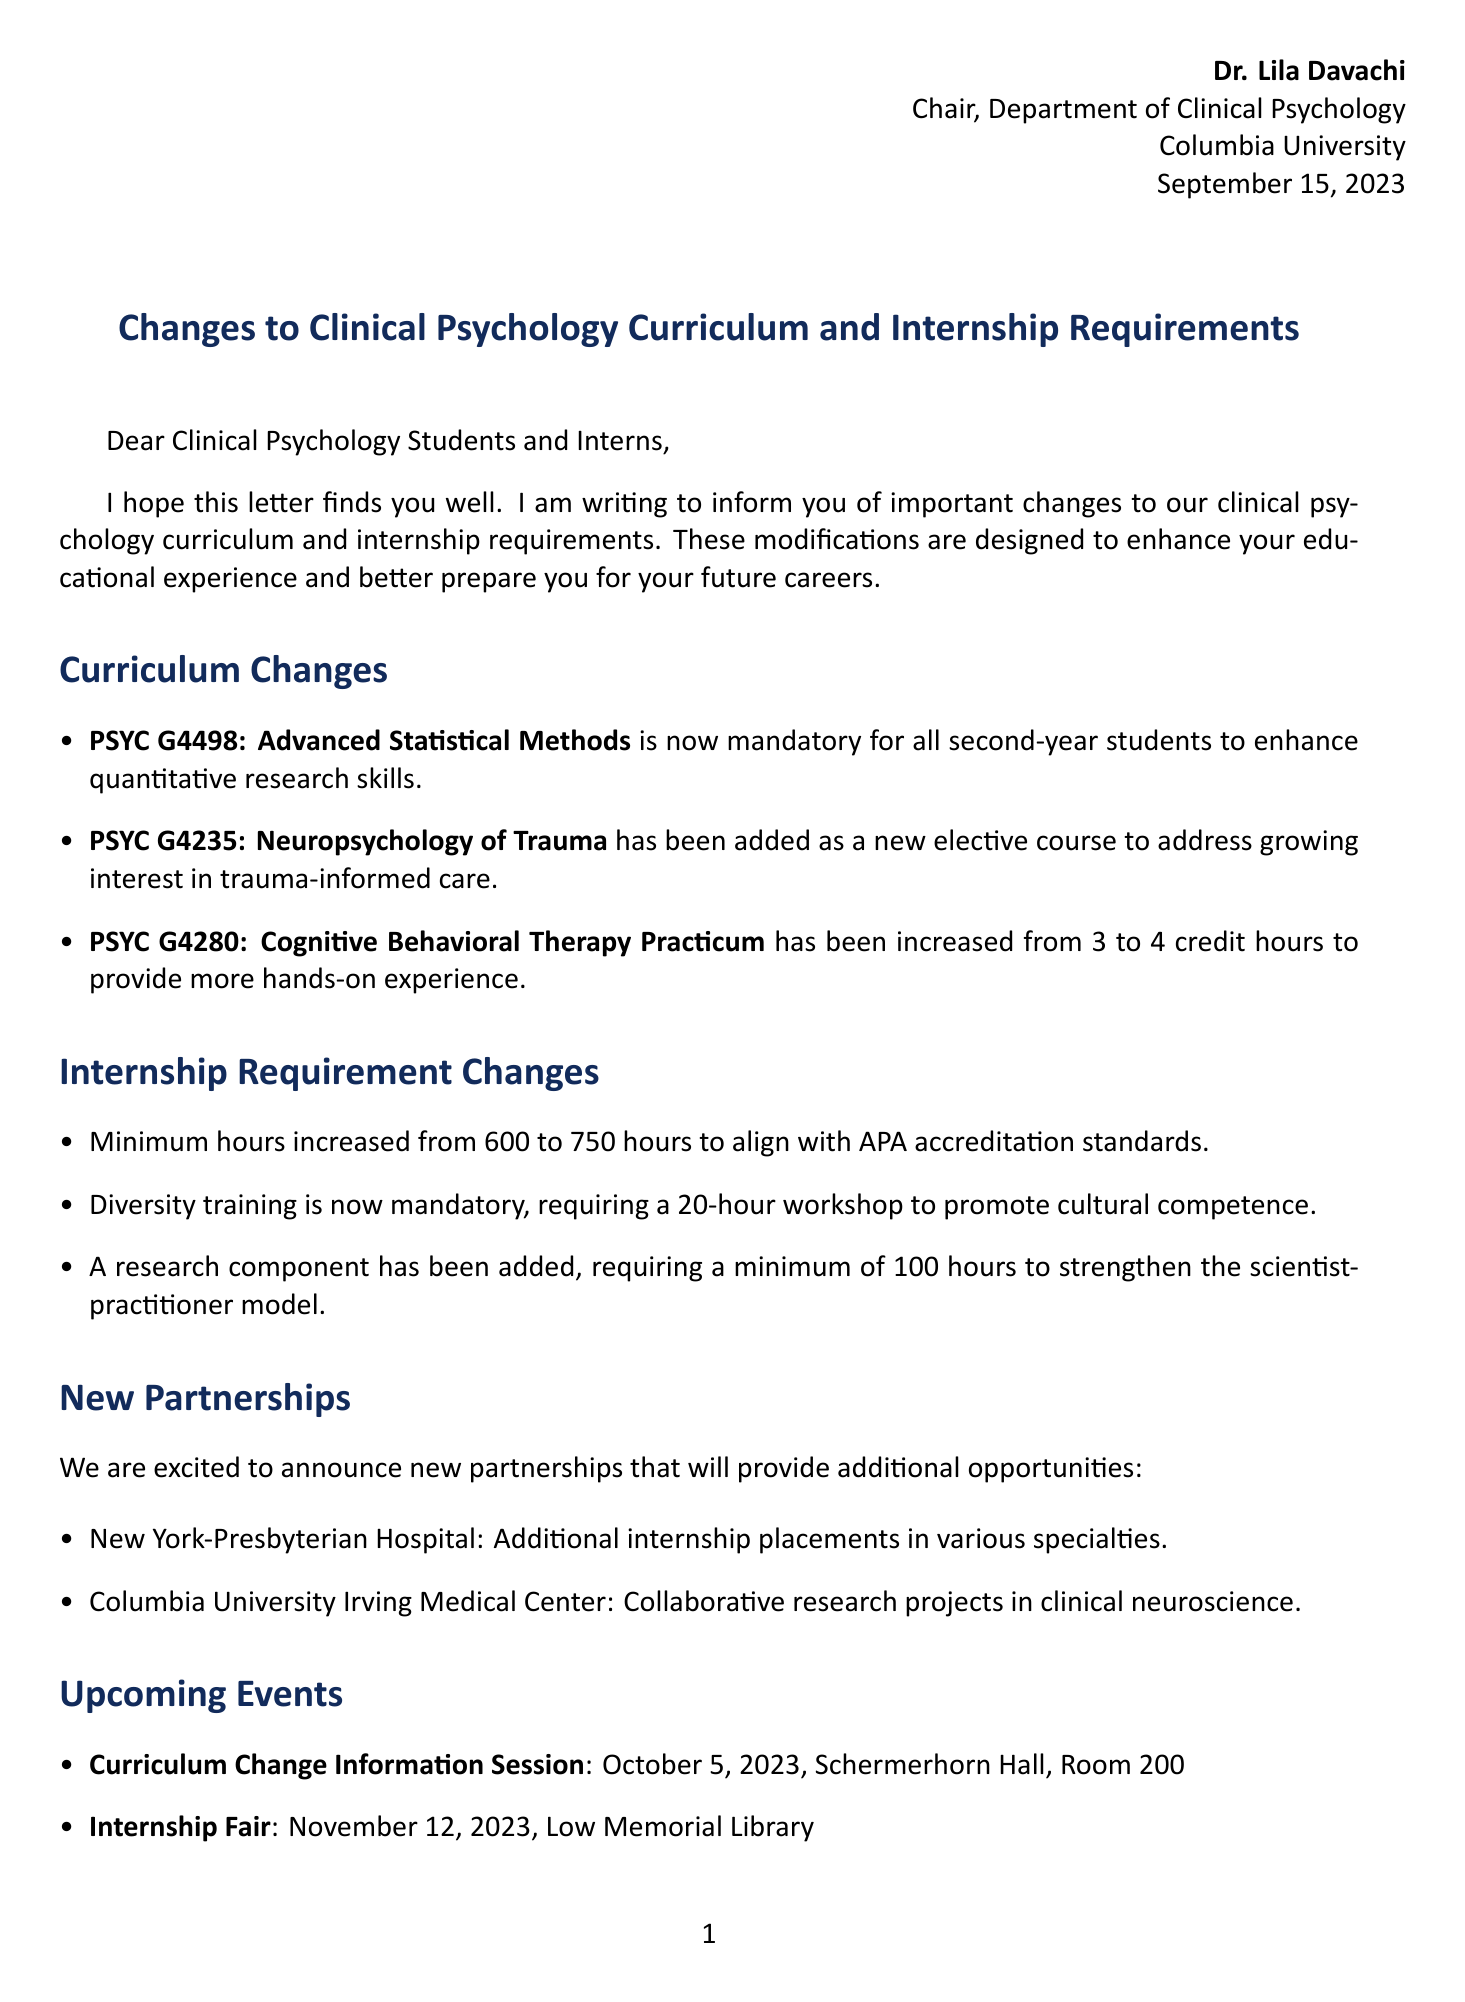What is the date of the letter? The date of the letter is specified in the header of the document.
Answer: September 15, 2023 Who is the sender of the letter? The sender is indicated at the beginning of the document as the person who wrote the letter.
Answer: Dr. Lila Davachi What is the new requirement for internship hours? The document lists the updated internship requirements in a specific section.
Answer: 750 hours What is the reason for adding the diversity training requirement? The reason is mentioned in the context of enhancing a particular competence among students.
Answer: To promote cultural competence When is the Curriculum Change Information Session scheduled? The date and details of the upcoming event are outlined in the events section of the document.
Answer: October 5, 2023 Which course has been made mandatory for all second-year students? The relevant curriculum change is listed with the course name specified.
Answer: PSYC G4498: Advanced Statistical Methods How many credit hours has the Cognitive Behavioral Therapy Practicum been increased to? The change is clearly stated along with its previous value.
Answer: 4 credit hours What new partnership was mentioned for additional internship placements? The document specifies partnerships that enhance internship opportunities.
Answer: New York-Presbyterian Hospital What is the title of the recipient in the letter? The recipient's title is implied in the salutation of the letter.
Answer: Clinical Psychology Students and Interns 